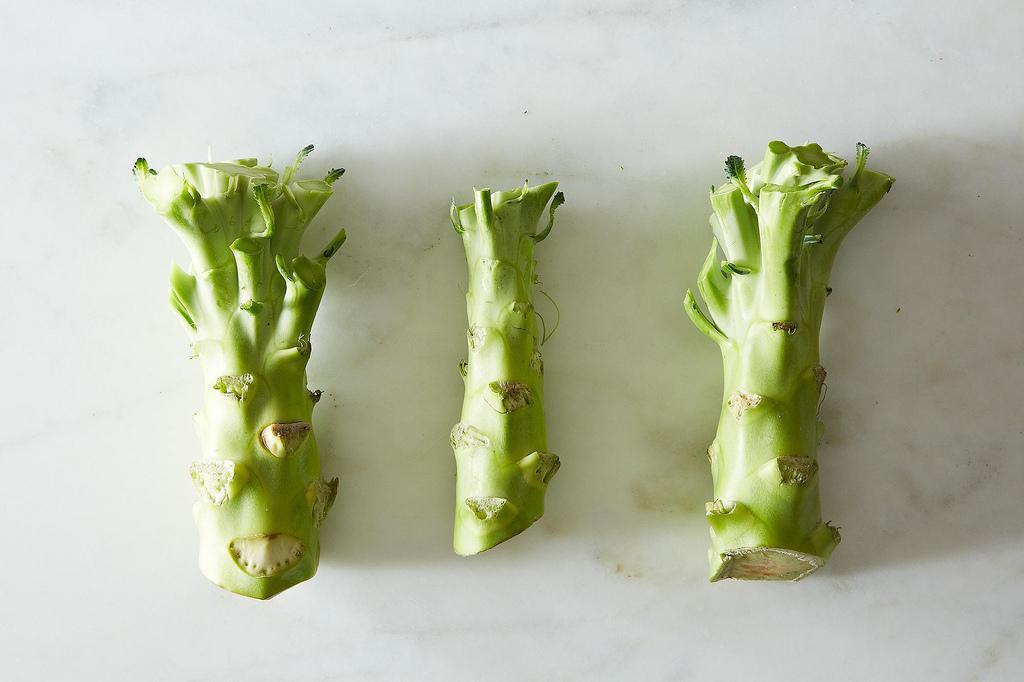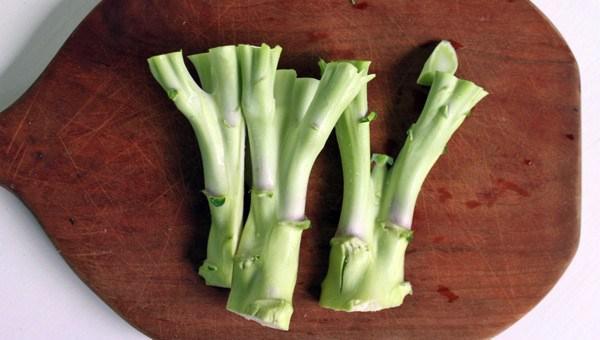The first image is the image on the left, the second image is the image on the right. Assess this claim about the two images: "There is fresh broccoli in a field.". Correct or not? Answer yes or no. No. The first image is the image on the left, the second image is the image on the right. Considering the images on both sides, is "In at least one image there is a total of one head of broccoli still growing on a stalk." valid? Answer yes or no. No. 